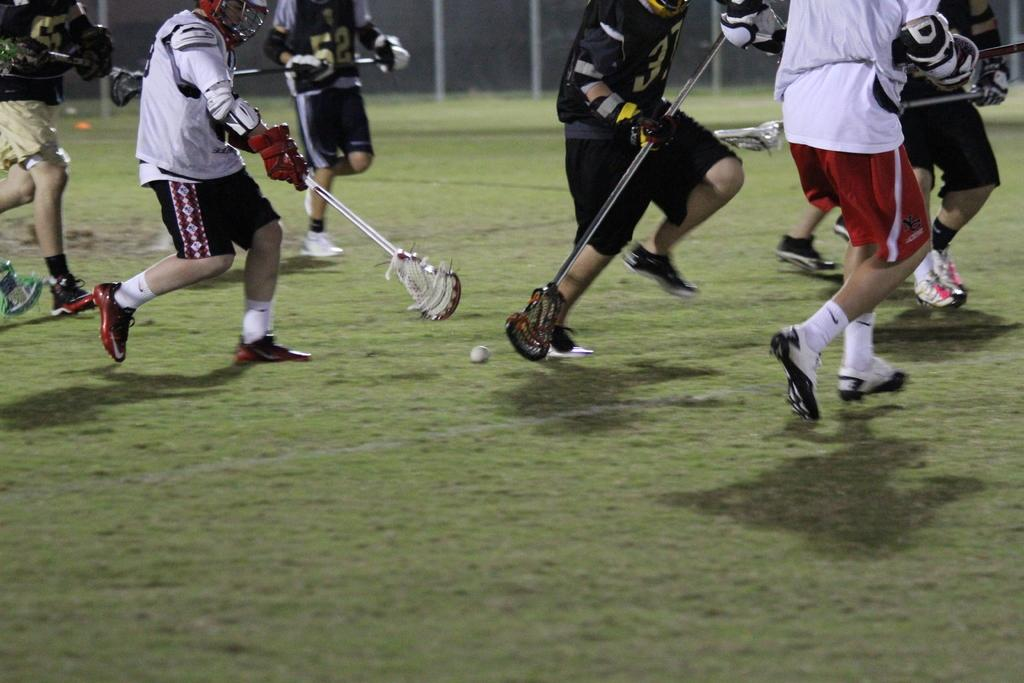What type of location is shown in the image? The image depicts a playing ground. What are the people in the image wearing? The people are wearing sports dresses in the image. What are the people holding in their hands? The people are holding bags in their hands. What activity are the people engaged in? The people are playing with a ball. What can be seen in the background of the image? There is a net fencing in the background of the image. What type of patch can be seen on the vegetable in the image? There is no vegetable present in the image, and therefore no patch can be observed. What color is the kite flying in the background of the image? There is no kite present in the image, so it cannot be determined what color it would be if it were there. 